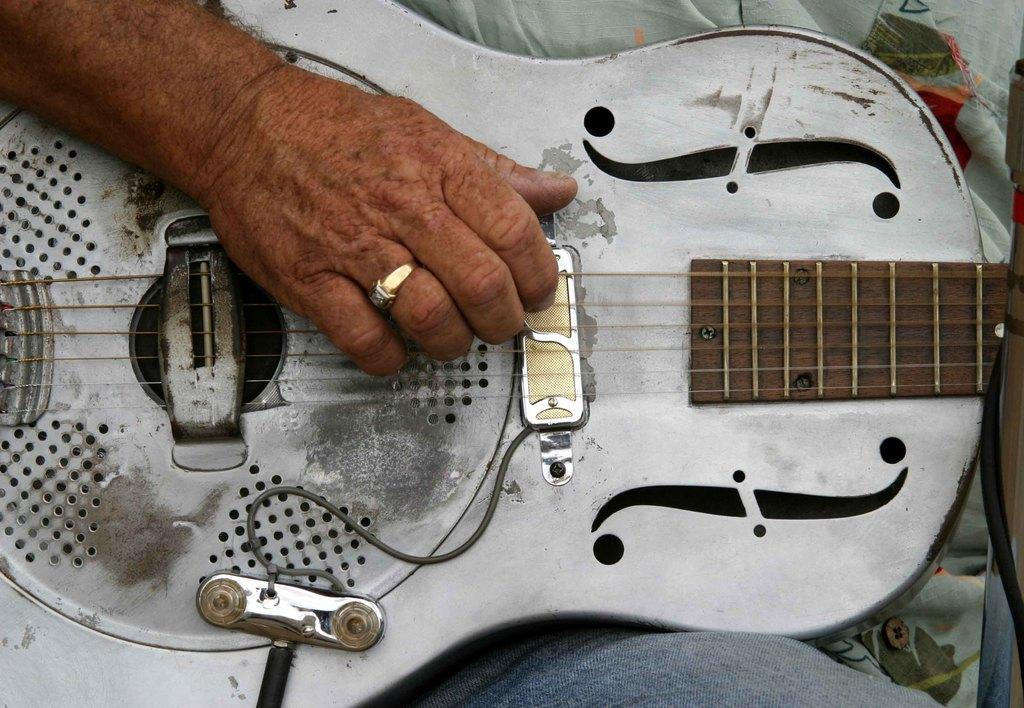What is the main subject of the image? There is a person in the image. What is the person holding in the image? The person is holding a guitar. What is the person doing with the guitar? The person is playing the guitar. What type of cable is the person using to play the guitar in the image? There is no cable visible in the image, and the person is playing the guitar without any visible cables. 